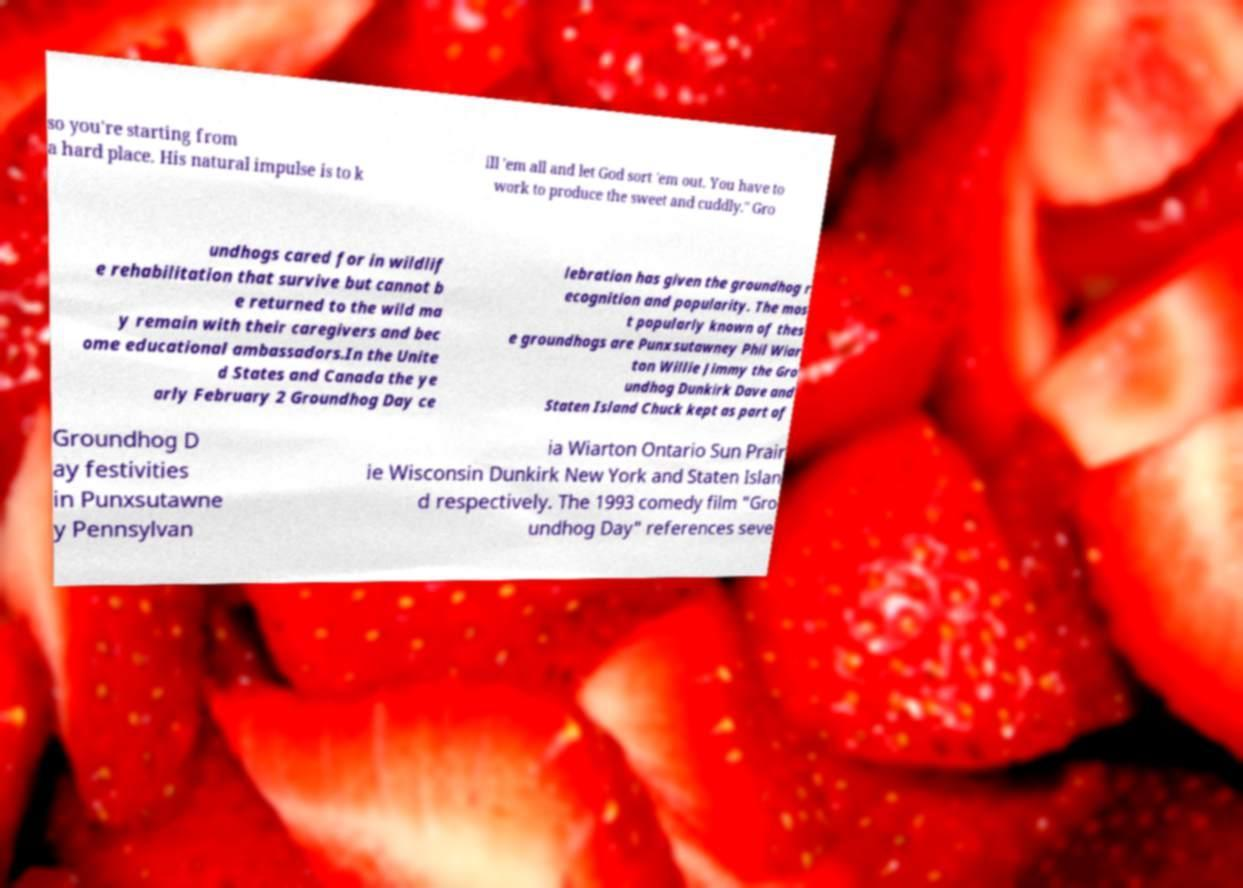Could you assist in decoding the text presented in this image and type it out clearly? so you're starting from a hard place. His natural impulse is to k ill 'em all and let God sort 'em out. You have to work to produce the sweet and cuddly." Gro undhogs cared for in wildlif e rehabilitation that survive but cannot b e returned to the wild ma y remain with their caregivers and bec ome educational ambassadors.In the Unite d States and Canada the ye arly February 2 Groundhog Day ce lebration has given the groundhog r ecognition and popularity. The mos t popularly known of thes e groundhogs are Punxsutawney Phil Wiar ton Willie Jimmy the Gro undhog Dunkirk Dave and Staten Island Chuck kept as part of Groundhog D ay festivities in Punxsutawne y Pennsylvan ia Wiarton Ontario Sun Prair ie Wisconsin Dunkirk New York and Staten Islan d respectively. The 1993 comedy film "Gro undhog Day" references seve 